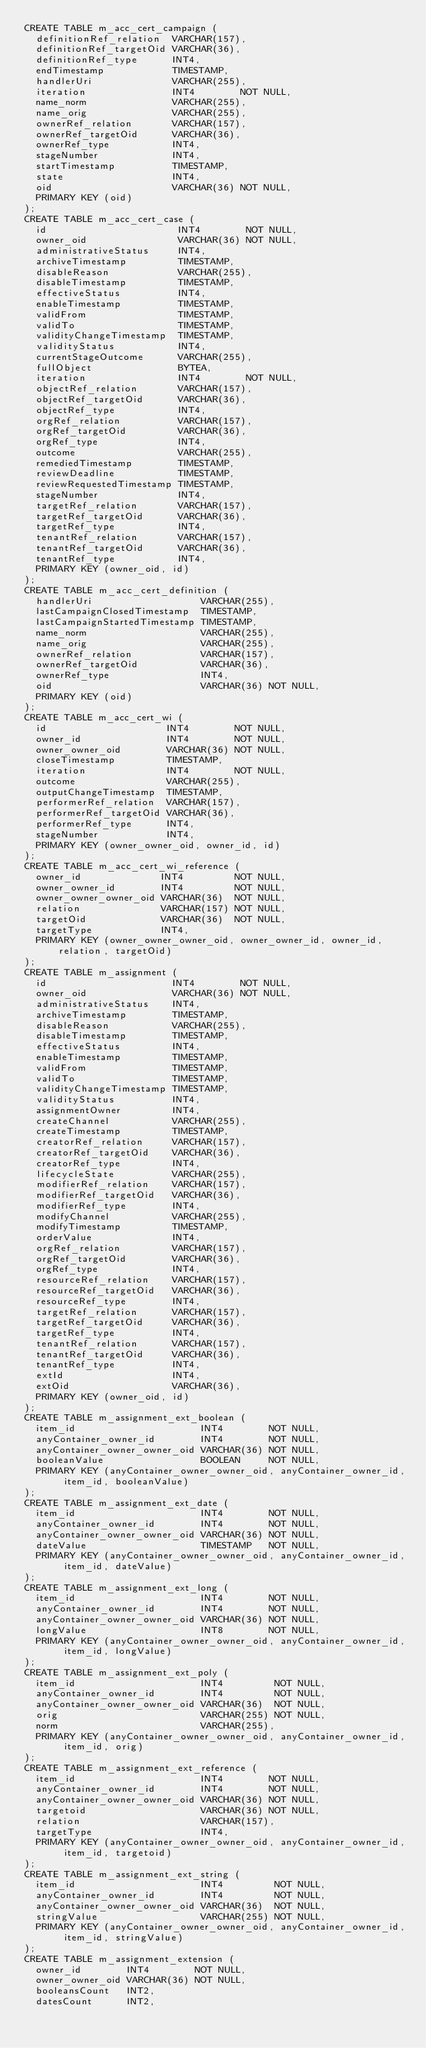<code> <loc_0><loc_0><loc_500><loc_500><_SQL_>CREATE TABLE m_acc_cert_campaign (
  definitionRef_relation  VARCHAR(157),
  definitionRef_targetOid VARCHAR(36),
  definitionRef_type      INT4,
  endTimestamp            TIMESTAMP,
  handlerUri              VARCHAR(255),
  iteration               INT4        NOT NULL,
  name_norm               VARCHAR(255),
  name_orig               VARCHAR(255),
  ownerRef_relation       VARCHAR(157),
  ownerRef_targetOid      VARCHAR(36),
  ownerRef_type           INT4,
  stageNumber             INT4,
  startTimestamp          TIMESTAMP,
  state                   INT4,
  oid                     VARCHAR(36) NOT NULL,
  PRIMARY KEY (oid)
);
CREATE TABLE m_acc_cert_case (
  id                       INT4        NOT NULL,
  owner_oid                VARCHAR(36) NOT NULL,
  administrativeStatus     INT4,
  archiveTimestamp         TIMESTAMP,
  disableReason            VARCHAR(255),
  disableTimestamp         TIMESTAMP,
  effectiveStatus          INT4,
  enableTimestamp          TIMESTAMP,
  validFrom                TIMESTAMP,
  validTo                  TIMESTAMP,
  validityChangeTimestamp  TIMESTAMP,
  validityStatus           INT4,
  currentStageOutcome      VARCHAR(255),
  fullObject               BYTEA,
  iteration                INT4        NOT NULL,
  objectRef_relation       VARCHAR(157),
  objectRef_targetOid      VARCHAR(36),
  objectRef_type           INT4,
  orgRef_relation          VARCHAR(157),
  orgRef_targetOid         VARCHAR(36),
  orgRef_type              INT4,
  outcome                  VARCHAR(255),
  remediedTimestamp        TIMESTAMP,
  reviewDeadline           TIMESTAMP,
  reviewRequestedTimestamp TIMESTAMP,
  stageNumber              INT4,
  targetRef_relation       VARCHAR(157),
  targetRef_targetOid      VARCHAR(36),
  targetRef_type           INT4,
  tenantRef_relation       VARCHAR(157),
  tenantRef_targetOid      VARCHAR(36),
  tenantRef_type           INT4,
  PRIMARY KEY (owner_oid, id)
);
CREATE TABLE m_acc_cert_definition (
  handlerUri                   VARCHAR(255),
  lastCampaignClosedTimestamp  TIMESTAMP,
  lastCampaignStartedTimestamp TIMESTAMP,
  name_norm                    VARCHAR(255),
  name_orig                    VARCHAR(255),
  ownerRef_relation            VARCHAR(157),
  ownerRef_targetOid           VARCHAR(36),
  ownerRef_type                INT4,
  oid                          VARCHAR(36) NOT NULL,
  PRIMARY KEY (oid)
);
CREATE TABLE m_acc_cert_wi (
  id                     INT4        NOT NULL,
  owner_id               INT4        NOT NULL,
  owner_owner_oid        VARCHAR(36) NOT NULL,
  closeTimestamp         TIMESTAMP,
  iteration              INT4        NOT NULL,
  outcome                VARCHAR(255),
  outputChangeTimestamp  TIMESTAMP,
  performerRef_relation  VARCHAR(157),
  performerRef_targetOid VARCHAR(36),
  performerRef_type      INT4,
  stageNumber            INT4,
  PRIMARY KEY (owner_owner_oid, owner_id, id)
);
CREATE TABLE m_acc_cert_wi_reference (
  owner_id              INT4         NOT NULL,
  owner_owner_id        INT4         NOT NULL,
  owner_owner_owner_oid VARCHAR(36)  NOT NULL,
  relation              VARCHAR(157) NOT NULL,
  targetOid             VARCHAR(36)  NOT NULL,
  targetType            INT4,
  PRIMARY KEY (owner_owner_owner_oid, owner_owner_id, owner_id, relation, targetOid)
);
CREATE TABLE m_assignment (
  id                      INT4        NOT NULL,
  owner_oid               VARCHAR(36) NOT NULL,
  administrativeStatus    INT4,
  archiveTimestamp        TIMESTAMP,
  disableReason           VARCHAR(255),
  disableTimestamp        TIMESTAMP,
  effectiveStatus         INT4,
  enableTimestamp         TIMESTAMP,
  validFrom               TIMESTAMP,
  validTo                 TIMESTAMP,
  validityChangeTimestamp TIMESTAMP,
  validityStatus          INT4,
  assignmentOwner         INT4,
  createChannel           VARCHAR(255),
  createTimestamp         TIMESTAMP,
  creatorRef_relation     VARCHAR(157),
  creatorRef_targetOid    VARCHAR(36),
  creatorRef_type         INT4,
  lifecycleState          VARCHAR(255),
  modifierRef_relation    VARCHAR(157),
  modifierRef_targetOid   VARCHAR(36),
  modifierRef_type        INT4,
  modifyChannel           VARCHAR(255),
  modifyTimestamp         TIMESTAMP,
  orderValue              INT4,
  orgRef_relation         VARCHAR(157),
  orgRef_targetOid        VARCHAR(36),
  orgRef_type             INT4,
  resourceRef_relation    VARCHAR(157),
  resourceRef_targetOid   VARCHAR(36),
  resourceRef_type        INT4,
  targetRef_relation      VARCHAR(157),
  targetRef_targetOid     VARCHAR(36),
  targetRef_type          INT4,
  tenantRef_relation      VARCHAR(157),
  tenantRef_targetOid     VARCHAR(36),
  tenantRef_type          INT4,
  extId                   INT4,
  extOid                  VARCHAR(36),
  PRIMARY KEY (owner_oid, id)
);
CREATE TABLE m_assignment_ext_boolean (
  item_id                      INT4        NOT NULL,
  anyContainer_owner_id        INT4        NOT NULL,
  anyContainer_owner_owner_oid VARCHAR(36) NOT NULL,
  booleanValue                 BOOLEAN     NOT NULL,
  PRIMARY KEY (anyContainer_owner_owner_oid, anyContainer_owner_id, item_id, booleanValue)
);
CREATE TABLE m_assignment_ext_date (
  item_id                      INT4        NOT NULL,
  anyContainer_owner_id        INT4        NOT NULL,
  anyContainer_owner_owner_oid VARCHAR(36) NOT NULL,
  dateValue                    TIMESTAMP   NOT NULL,
  PRIMARY KEY (anyContainer_owner_owner_oid, anyContainer_owner_id, item_id, dateValue)
);
CREATE TABLE m_assignment_ext_long (
  item_id                      INT4        NOT NULL,
  anyContainer_owner_id        INT4        NOT NULL,
  anyContainer_owner_owner_oid VARCHAR(36) NOT NULL,
  longValue                    INT8        NOT NULL,
  PRIMARY KEY (anyContainer_owner_owner_oid, anyContainer_owner_id, item_id, longValue)
);
CREATE TABLE m_assignment_ext_poly (
  item_id                      INT4         NOT NULL,
  anyContainer_owner_id        INT4         NOT NULL,
  anyContainer_owner_owner_oid VARCHAR(36)  NOT NULL,
  orig                         VARCHAR(255) NOT NULL,
  norm                         VARCHAR(255),
  PRIMARY KEY (anyContainer_owner_owner_oid, anyContainer_owner_id, item_id, orig)
);
CREATE TABLE m_assignment_ext_reference (
  item_id                      INT4        NOT NULL,
  anyContainer_owner_id        INT4        NOT NULL,
  anyContainer_owner_owner_oid VARCHAR(36) NOT NULL,
  targetoid                    VARCHAR(36) NOT NULL,
  relation                     VARCHAR(157),
  targetType                   INT4,
  PRIMARY KEY (anyContainer_owner_owner_oid, anyContainer_owner_id, item_id, targetoid)
);
CREATE TABLE m_assignment_ext_string (
  item_id                      INT4         NOT NULL,
  anyContainer_owner_id        INT4         NOT NULL,
  anyContainer_owner_owner_oid VARCHAR(36)  NOT NULL,
  stringValue                  VARCHAR(255) NOT NULL,
  PRIMARY KEY (anyContainer_owner_owner_oid, anyContainer_owner_id, item_id, stringValue)
);
CREATE TABLE m_assignment_extension (
  owner_id        INT4        NOT NULL,
  owner_owner_oid VARCHAR(36) NOT NULL,
  booleansCount   INT2,
  datesCount      INT2,</code> 